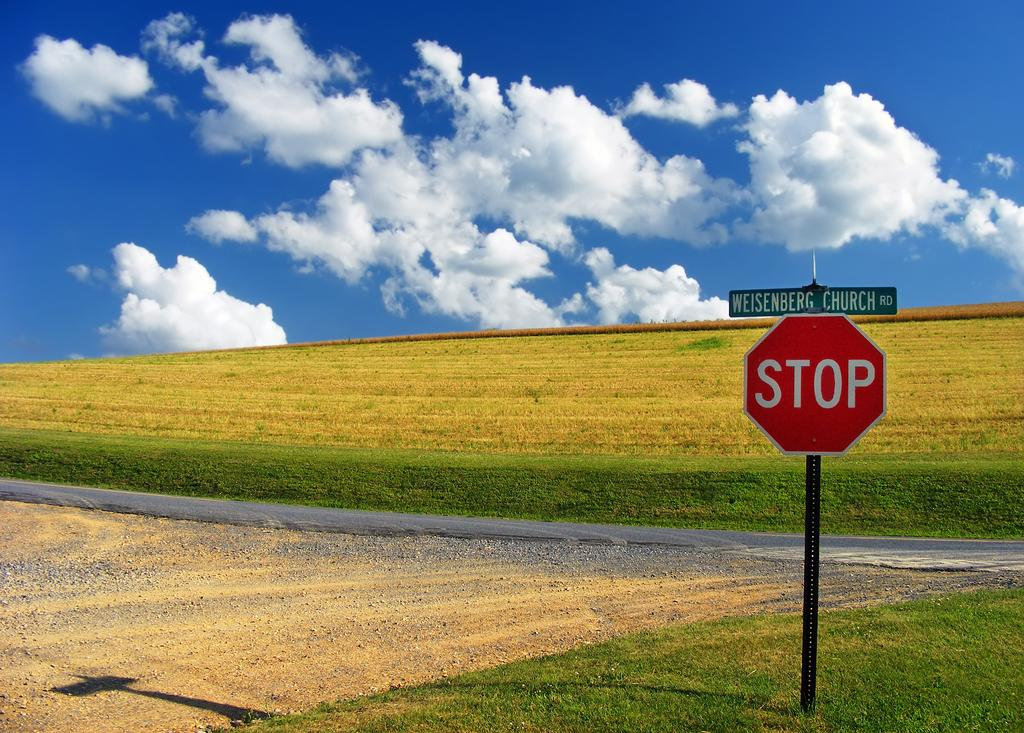<image>
Summarize the visual content of the image. A stop sign is below a street sign for Weisenberg Church road. 